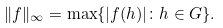Convert formula to latex. <formula><loc_0><loc_0><loc_500><loc_500>\| f \| _ { \infty } = \max \{ | f ( h ) | \colon h \in G \} .</formula> 